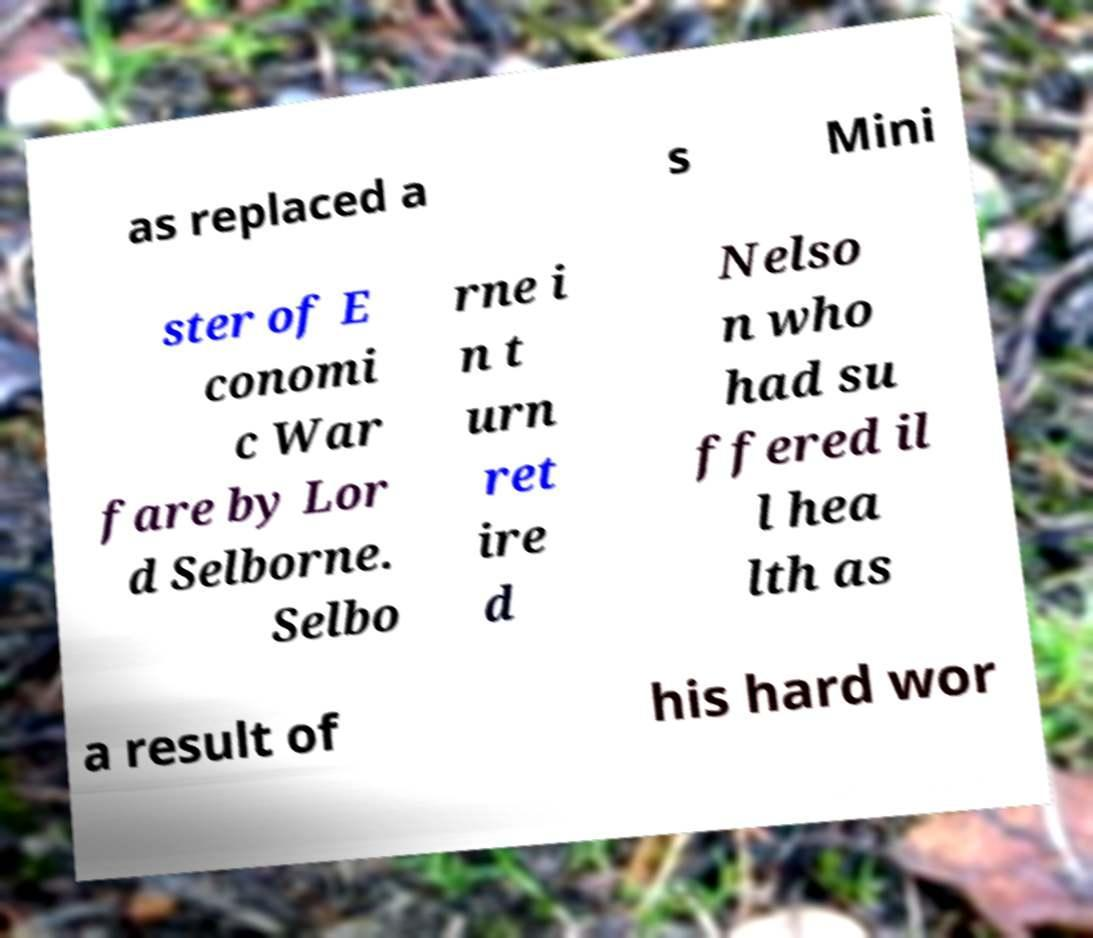What messages or text are displayed in this image? I need them in a readable, typed format. as replaced a s Mini ster of E conomi c War fare by Lor d Selborne. Selbo rne i n t urn ret ire d Nelso n who had su ffered il l hea lth as a result of his hard wor 